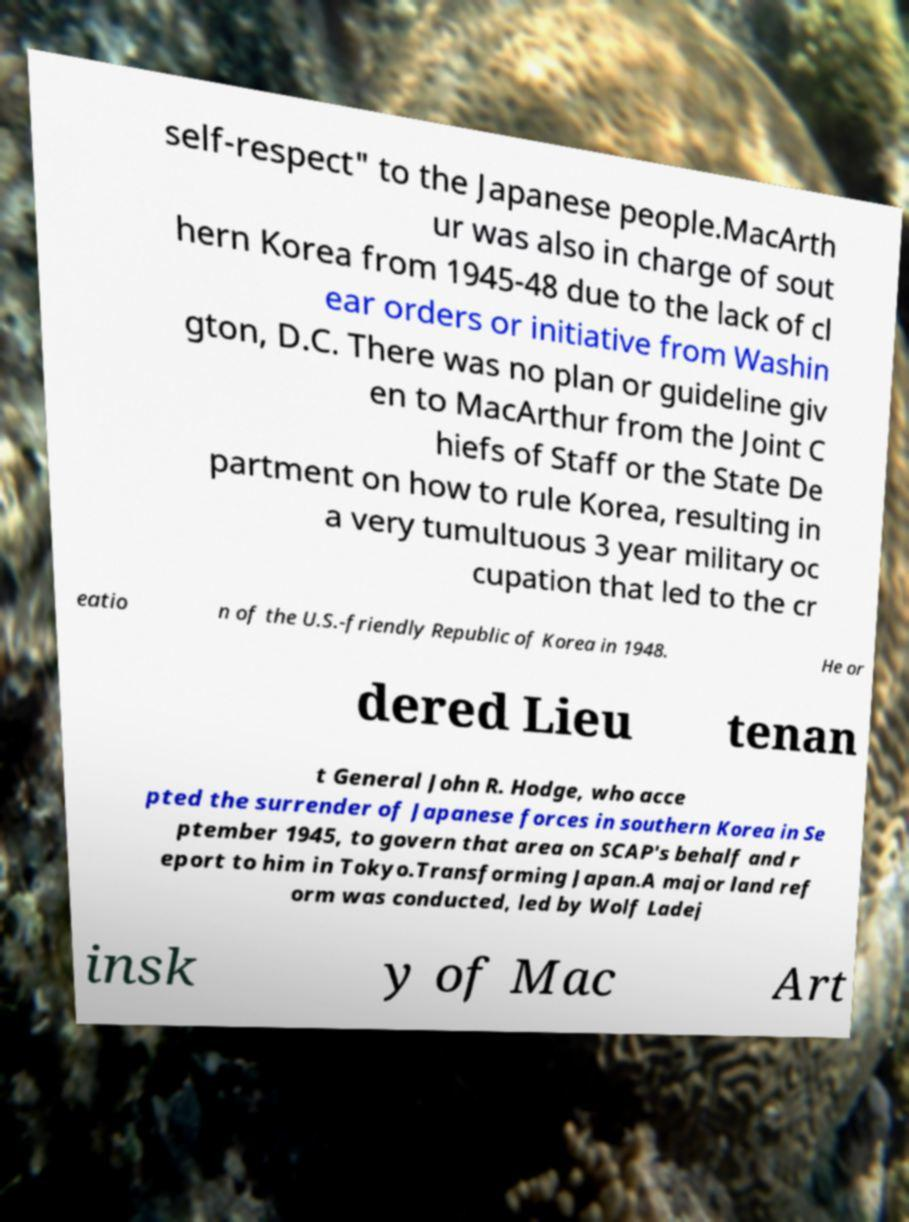I need the written content from this picture converted into text. Can you do that? self-respect" to the Japanese people.MacArth ur was also in charge of sout hern Korea from 1945-48 due to the lack of cl ear orders or initiative from Washin gton, D.C. There was no plan or guideline giv en to MacArthur from the Joint C hiefs of Staff or the State De partment on how to rule Korea, resulting in a very tumultuous 3 year military oc cupation that led to the cr eatio n of the U.S.-friendly Republic of Korea in 1948. He or dered Lieu tenan t General John R. Hodge, who acce pted the surrender of Japanese forces in southern Korea in Se ptember 1945, to govern that area on SCAP's behalf and r eport to him in Tokyo.Transforming Japan.A major land ref orm was conducted, led by Wolf Ladej insk y of Mac Art 